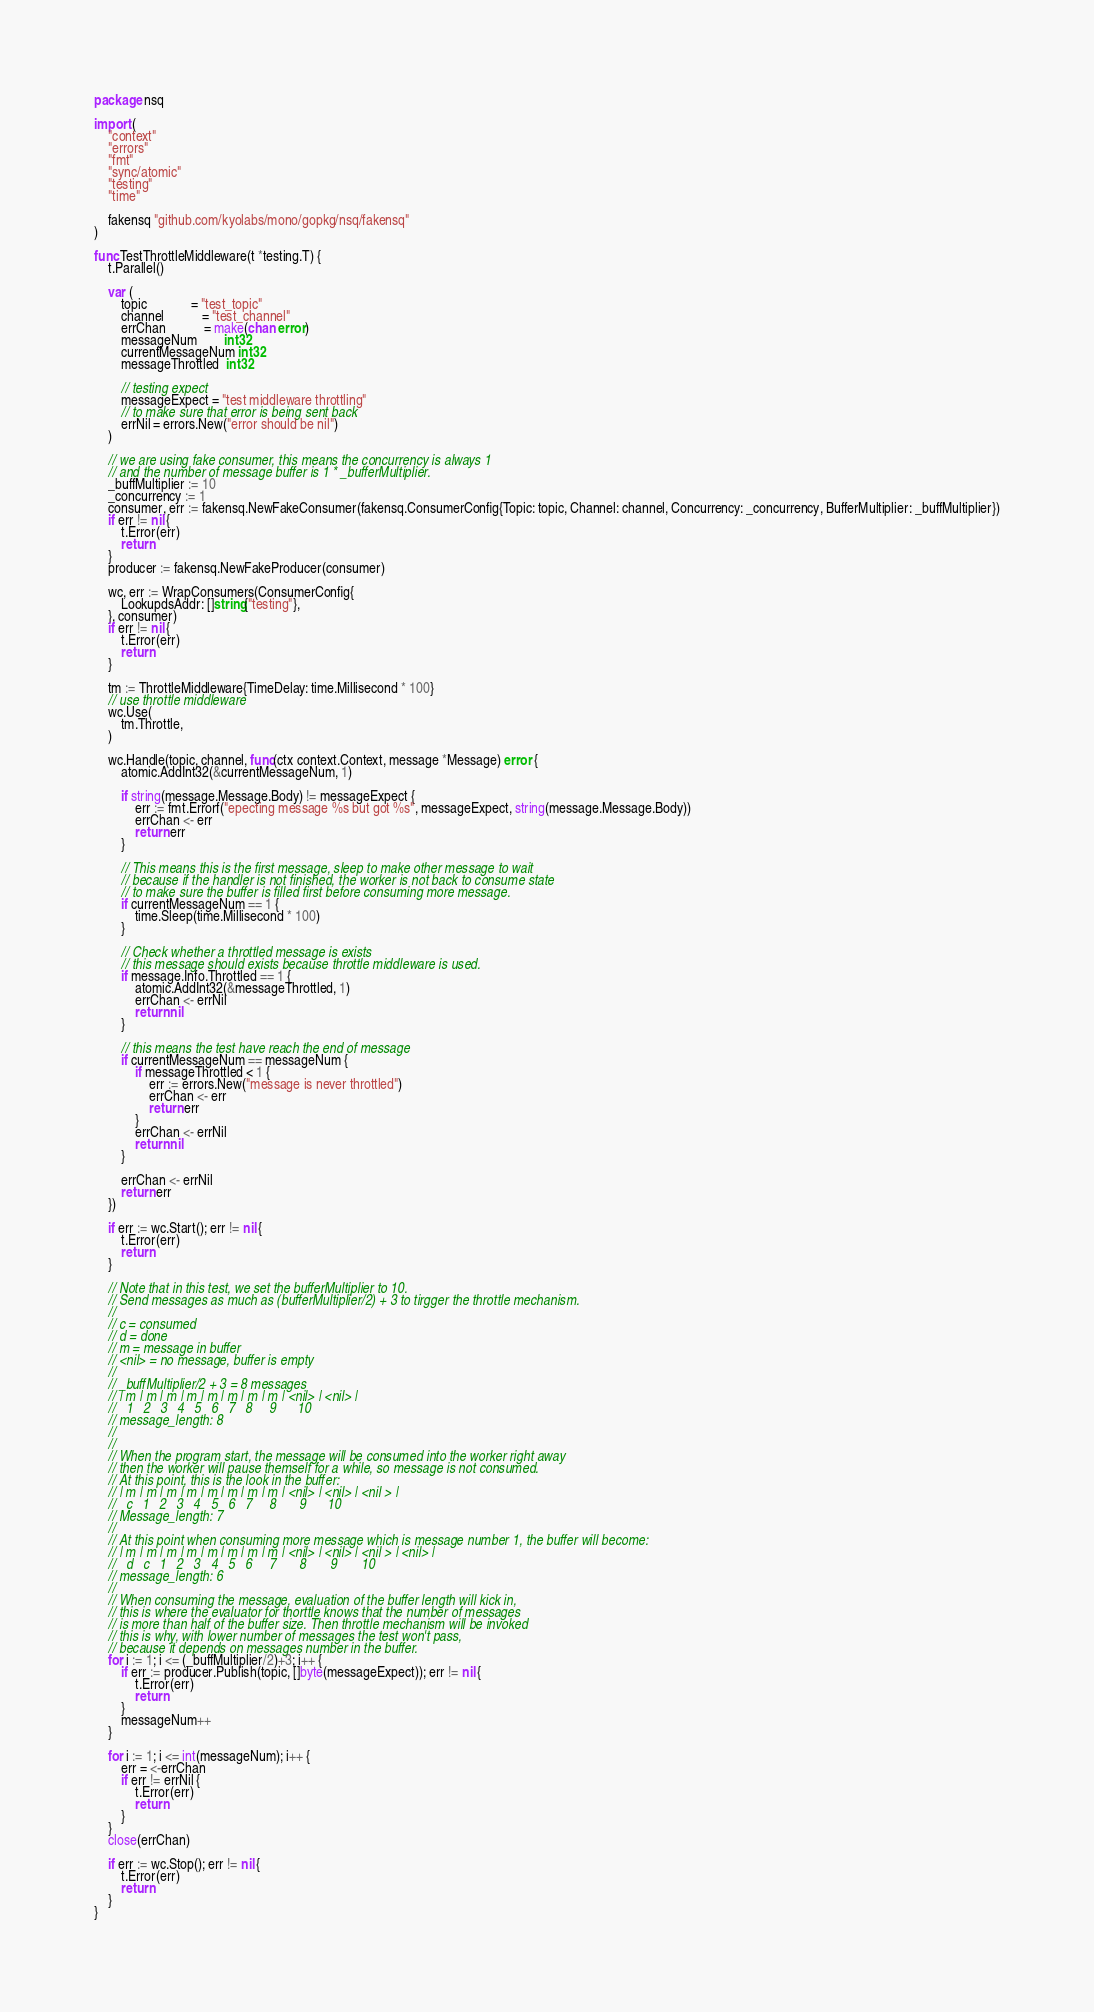<code> <loc_0><loc_0><loc_500><loc_500><_Go_>package nsq

import (
	"context"
	"errors"
	"fmt"
	"sync/atomic"
	"testing"
	"time"

	fakensq "github.com/kyolabs/mono/gopkg/nsq/fakensq"
)

func TestThrottleMiddleware(t *testing.T) {
	t.Parallel()

	var (
		topic             = "test_topic"
		channel           = "test_channel"
		errChan           = make(chan error)
		messageNum        int32
		currentMessageNum int32
		messageThrottled  int32

		// testing expect
		messageExpect = "test middleware throttling"
		// to make sure that error is being sent back
		errNil = errors.New("error should be nil")
	)

	// we are using fake consumer, this means the concurrency is always 1
	// and the number of message buffer is 1 * _bufferMultiplier.
	_buffMultiplier := 10
	_concurrency := 1
	consumer, err := fakensq.NewFakeConsumer(fakensq.ConsumerConfig{Topic: topic, Channel: channel, Concurrency: _concurrency, BufferMultiplier: _buffMultiplier})
	if err != nil {
		t.Error(err)
		return
	}
	producer := fakensq.NewFakeProducer(consumer)

	wc, err := WrapConsumers(ConsumerConfig{
		LookupdsAddr: []string{"testing"},
	}, consumer)
	if err != nil {
		t.Error(err)
		return
	}

	tm := ThrottleMiddleware{TimeDelay: time.Millisecond * 100}
	// use throttle middleware
	wc.Use(
		tm.Throttle,
	)

	wc.Handle(topic, channel, func(ctx context.Context, message *Message) error {
		atomic.AddInt32(&currentMessageNum, 1)

		if string(message.Message.Body) != messageExpect {
			err := fmt.Errorf("epecting message %s but got %s", messageExpect, string(message.Message.Body))
			errChan <- err
			return err
		}

		// This means this is the first message, sleep to make other message to wait
		// because if the handler is not finished, the worker is not back to consume state
		// to make sure the buffer is filled first before consuming more message.
		if currentMessageNum == 1 {
			time.Sleep(time.Millisecond * 100)
		}

		// Check whether a throttled message is exists
		// this message should exists because throttle middleware is used.
		if message.Info.Throttled == 1 {
			atomic.AddInt32(&messageThrottled, 1)
			errChan <- errNil
			return nil
		}

		// this means the test have reach the end of message
		if currentMessageNum == messageNum {
			if messageThrottled < 1 {
				err := errors.New("message is never throttled")
				errChan <- err
				return err
			}
			errChan <- errNil
			return nil
		}

		errChan <- errNil
		return err
	})

	if err := wc.Start(); err != nil {
		t.Error(err)
		return
	}

	// Note that in this test, we set the bufferMultiplier to 10.
	// Send messages as much as (bufferMultiplier/2) + 3 to tirgger the throttle mechanism.
	//
	// c = consumed
	// d = done
	// m = message in buffer
	// <nil> = no message, buffer is empty
	//
	// _buffMultiplier/2 + 3 = 8 messages
	// | m | m | m | m | m | m | m | m | <nil> | <nil> |
	//   1   2   3   4   5   6   7   8     9      10
	// message_length: 8
	//
	//
	// When the program start, the message will be consumed into the worker right away
	// then the worker will pause themself for a while, so message is not consumed.
	// At this point, this is the look in the buffer:
	// | m | m | m | m | m | m | m | m | <nil> | <nil> | <nil > |
	//   c   1   2   3   4   5   6   7     8       9      10
	// Message_length: 7
	//
	// At this point when consuming more message which is message number 1, the buffer will become:
	// | m | m | m | m | m | m | m | m | <nil> | <nil> | <nil > | <nil> |
	//   d   c   1   2   3   4   5   6     7       8       9       10
	// message_length: 6
	//
	// When consuming the message, evaluation of the buffer length will kick in,
	// this is where the evaluator for thorttle knows that the number of messages
	// is more than half of the buffer size. Then throttle mechanism will be invoked
	// this is why, with lower number of messages the test won't pass,
	// because it depends on messages number in the buffer.
	for i := 1; i <= (_buffMultiplier/2)+3; i++ {
		if err := producer.Publish(topic, []byte(messageExpect)); err != nil {
			t.Error(err)
			return
		}
		messageNum++
	}

	for i := 1; i <= int(messageNum); i++ {
		err = <-errChan
		if err != errNil {
			t.Error(err)
			return
		}
	}
	close(errChan)

	if err := wc.Stop(); err != nil {
		t.Error(err)
		return
	}
}
</code> 